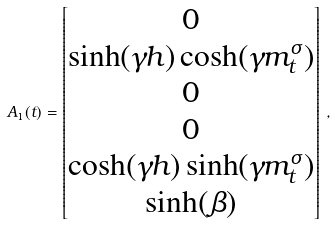<formula> <loc_0><loc_0><loc_500><loc_500>A _ { 1 } ( t ) = \begin{bmatrix} 0 \\ \sinh ( \gamma h ) \cosh ( \gamma m ^ { \sigma } _ { t } ) \\ 0 \\ 0 \\ \cosh ( \gamma h ) \sinh ( \gamma m ^ { \sigma } _ { t } ) \\ \sinh ( \beta ) \end{bmatrix} \, ,</formula> 